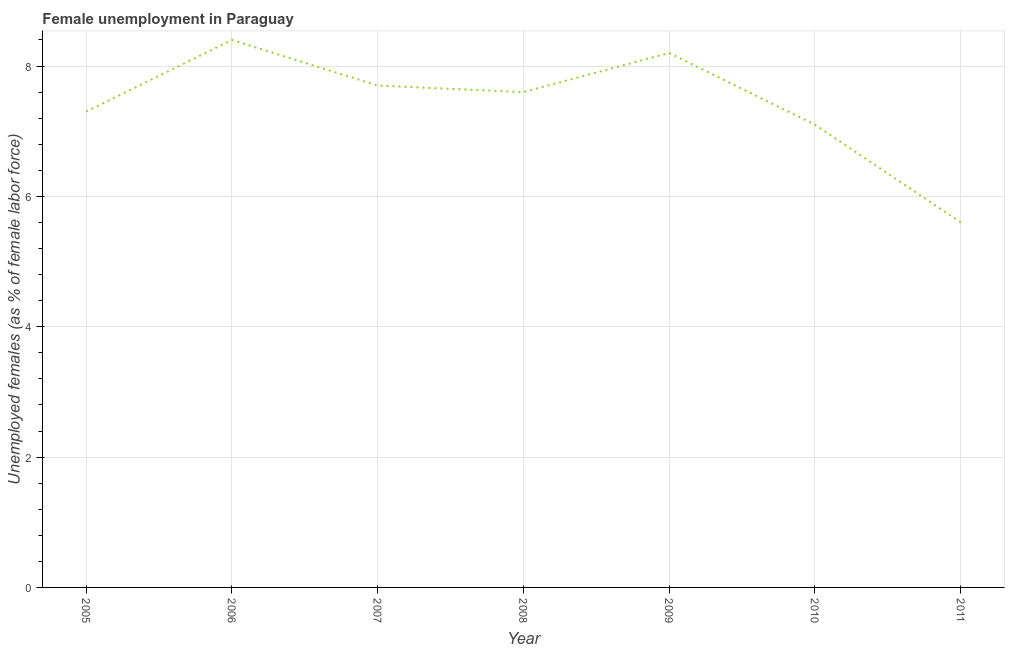What is the unemployed females population in 2005?
Your answer should be compact. 7.3. Across all years, what is the maximum unemployed females population?
Keep it short and to the point. 8.4. Across all years, what is the minimum unemployed females population?
Your answer should be compact. 5.6. In which year was the unemployed females population maximum?
Make the answer very short. 2006. In which year was the unemployed females population minimum?
Make the answer very short. 2011. What is the sum of the unemployed females population?
Keep it short and to the point. 51.9. What is the difference between the unemployed females population in 2005 and 2009?
Ensure brevity in your answer.  -0.9. What is the average unemployed females population per year?
Give a very brief answer. 7.41. What is the median unemployed females population?
Your response must be concise. 7.6. In how many years, is the unemployed females population greater than 0.8 %?
Your response must be concise. 7. What is the ratio of the unemployed females population in 2008 to that in 2011?
Offer a very short reply. 1.36. Is the unemployed females population in 2006 less than that in 2011?
Ensure brevity in your answer.  No. Is the difference between the unemployed females population in 2005 and 2010 greater than the difference between any two years?
Your answer should be very brief. No. What is the difference between the highest and the second highest unemployed females population?
Your answer should be compact. 0.2. What is the difference between the highest and the lowest unemployed females population?
Keep it short and to the point. 2.8. In how many years, is the unemployed females population greater than the average unemployed females population taken over all years?
Offer a very short reply. 4. Does the unemployed females population monotonically increase over the years?
Give a very brief answer. No. How many lines are there?
Keep it short and to the point. 1. How many years are there in the graph?
Give a very brief answer. 7. What is the title of the graph?
Provide a short and direct response. Female unemployment in Paraguay. What is the label or title of the Y-axis?
Provide a succinct answer. Unemployed females (as % of female labor force). What is the Unemployed females (as % of female labor force) in 2005?
Offer a terse response. 7.3. What is the Unemployed females (as % of female labor force) of 2006?
Ensure brevity in your answer.  8.4. What is the Unemployed females (as % of female labor force) of 2007?
Your answer should be very brief. 7.7. What is the Unemployed females (as % of female labor force) in 2008?
Your answer should be very brief. 7.6. What is the Unemployed females (as % of female labor force) of 2009?
Your answer should be compact. 8.2. What is the Unemployed females (as % of female labor force) of 2010?
Make the answer very short. 7.1. What is the Unemployed females (as % of female labor force) of 2011?
Keep it short and to the point. 5.6. What is the difference between the Unemployed females (as % of female labor force) in 2005 and 2006?
Offer a very short reply. -1.1. What is the difference between the Unemployed females (as % of female labor force) in 2005 and 2008?
Provide a succinct answer. -0.3. What is the difference between the Unemployed females (as % of female labor force) in 2005 and 2009?
Your answer should be compact. -0.9. What is the difference between the Unemployed females (as % of female labor force) in 2005 and 2011?
Your answer should be compact. 1.7. What is the difference between the Unemployed females (as % of female labor force) in 2006 and 2010?
Offer a terse response. 1.3. What is the difference between the Unemployed females (as % of female labor force) in 2006 and 2011?
Offer a terse response. 2.8. What is the difference between the Unemployed females (as % of female labor force) in 2007 and 2008?
Provide a short and direct response. 0.1. What is the difference between the Unemployed females (as % of female labor force) in 2007 and 2011?
Ensure brevity in your answer.  2.1. What is the difference between the Unemployed females (as % of female labor force) in 2008 and 2010?
Keep it short and to the point. 0.5. What is the difference between the Unemployed females (as % of female labor force) in 2009 and 2010?
Offer a terse response. 1.1. What is the ratio of the Unemployed females (as % of female labor force) in 2005 to that in 2006?
Your answer should be compact. 0.87. What is the ratio of the Unemployed females (as % of female labor force) in 2005 to that in 2007?
Offer a terse response. 0.95. What is the ratio of the Unemployed females (as % of female labor force) in 2005 to that in 2009?
Your answer should be compact. 0.89. What is the ratio of the Unemployed females (as % of female labor force) in 2005 to that in 2010?
Provide a succinct answer. 1.03. What is the ratio of the Unemployed females (as % of female labor force) in 2005 to that in 2011?
Your answer should be very brief. 1.3. What is the ratio of the Unemployed females (as % of female labor force) in 2006 to that in 2007?
Provide a short and direct response. 1.09. What is the ratio of the Unemployed females (as % of female labor force) in 2006 to that in 2008?
Provide a short and direct response. 1.1. What is the ratio of the Unemployed females (as % of female labor force) in 2006 to that in 2009?
Your response must be concise. 1.02. What is the ratio of the Unemployed females (as % of female labor force) in 2006 to that in 2010?
Provide a succinct answer. 1.18. What is the ratio of the Unemployed females (as % of female labor force) in 2007 to that in 2009?
Provide a succinct answer. 0.94. What is the ratio of the Unemployed females (as % of female labor force) in 2007 to that in 2010?
Your response must be concise. 1.08. What is the ratio of the Unemployed females (as % of female labor force) in 2007 to that in 2011?
Ensure brevity in your answer.  1.38. What is the ratio of the Unemployed females (as % of female labor force) in 2008 to that in 2009?
Ensure brevity in your answer.  0.93. What is the ratio of the Unemployed females (as % of female labor force) in 2008 to that in 2010?
Give a very brief answer. 1.07. What is the ratio of the Unemployed females (as % of female labor force) in 2008 to that in 2011?
Give a very brief answer. 1.36. What is the ratio of the Unemployed females (as % of female labor force) in 2009 to that in 2010?
Provide a succinct answer. 1.16. What is the ratio of the Unemployed females (as % of female labor force) in 2009 to that in 2011?
Offer a terse response. 1.46. What is the ratio of the Unemployed females (as % of female labor force) in 2010 to that in 2011?
Offer a terse response. 1.27. 